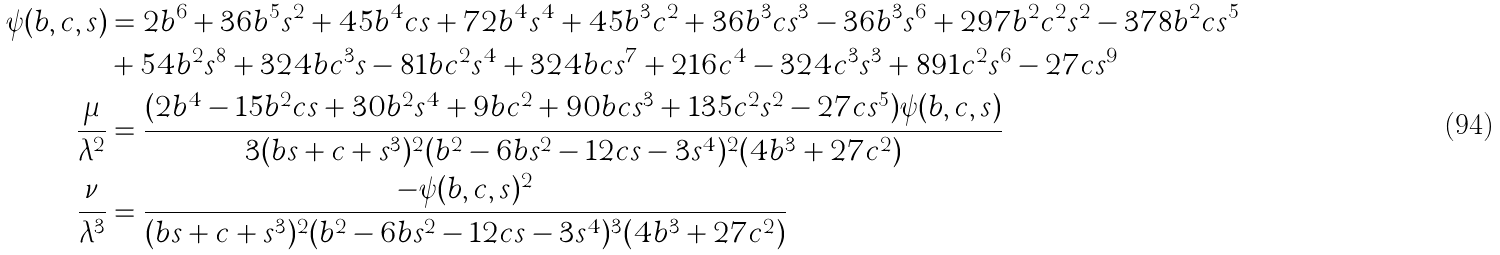Convert formula to latex. <formula><loc_0><loc_0><loc_500><loc_500>\psi ( b , c , s ) & = 2 b ^ { 6 } + 3 6 b ^ { 5 } s ^ { 2 } + 4 5 b ^ { 4 } c s + 7 2 b ^ { 4 } s ^ { 4 } + 4 5 b ^ { 3 } c ^ { 2 } + 3 6 b ^ { 3 } c s ^ { 3 } - 3 6 b ^ { 3 } s ^ { 6 } + 2 9 7 b ^ { 2 } c ^ { 2 } s ^ { 2 } - 3 7 8 b ^ { 2 } c s ^ { 5 } \\ & + 5 4 b ^ { 2 } s ^ { 8 } + 3 2 4 b c ^ { 3 } s - 8 1 b c ^ { 2 } s ^ { 4 } + 3 2 4 b c s ^ { 7 } + 2 1 6 c ^ { 4 } - 3 2 4 c ^ { 3 } s ^ { 3 } + 8 9 1 c ^ { 2 } s ^ { 6 } - 2 7 c s ^ { 9 } \\ \frac { \mu } { \lambda ^ { 2 } } & = \frac { ( 2 b ^ { 4 } - 1 5 b ^ { 2 } c s + 3 0 b ^ { 2 } s ^ { 4 } + 9 b c ^ { 2 } + 9 0 b c s ^ { 3 } + 1 3 5 c ^ { 2 } s ^ { 2 } - 2 7 c s ^ { 5 } ) \psi ( b , c , s ) } { 3 ( b s + c + s ^ { 3 } ) ^ { 2 } ( b ^ { 2 } - 6 b s ^ { 2 } - 1 2 c s - 3 s ^ { 4 } ) ^ { 2 } ( 4 b ^ { 3 } + 2 7 c ^ { 2 } ) } \\ \frac { \nu } { \lambda ^ { 3 } } & = \frac { - \psi ( b , c , s ) ^ { 2 } } { ( b s + c + s ^ { 3 } ) ^ { 2 } ( b ^ { 2 } - 6 b s ^ { 2 } - 1 2 c s - 3 s ^ { 4 } ) ^ { 3 } ( 4 b ^ { 3 } + 2 7 c ^ { 2 } ) }</formula> 